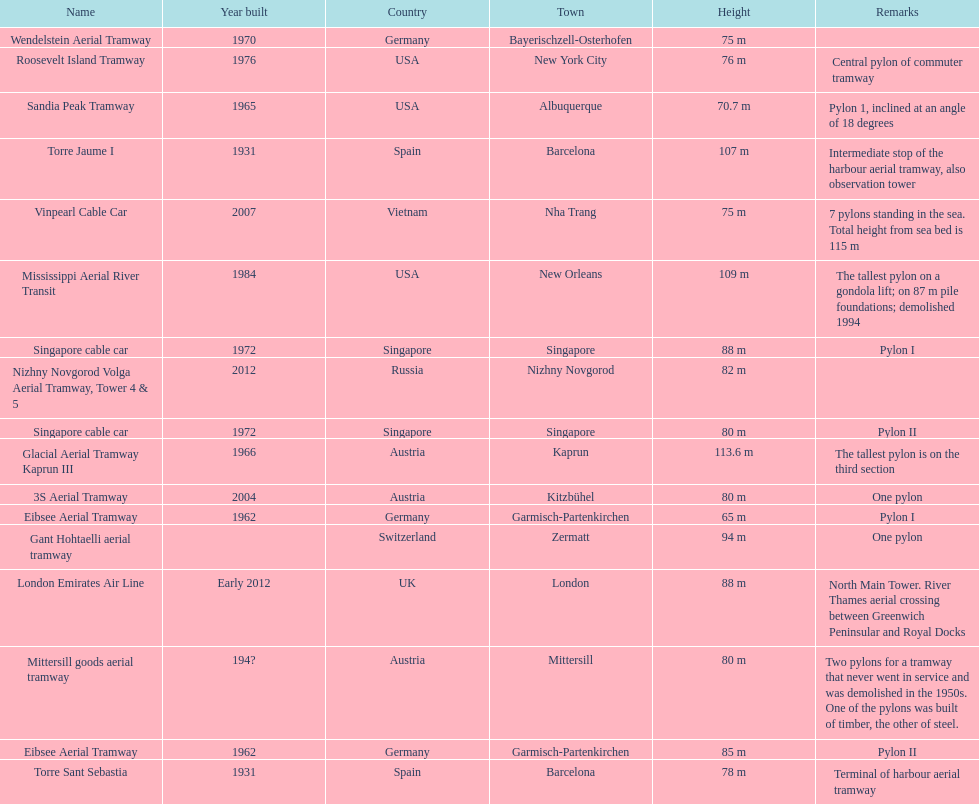How many metres is the tallest pylon? 113.6 m. 